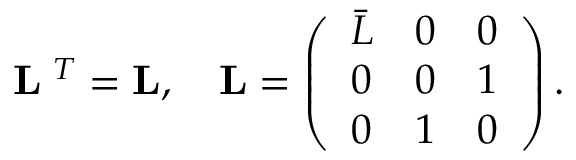Convert formula to latex. <formula><loc_0><loc_0><loc_500><loc_500>{ \Omega } { L } { \Omega } ^ { T } = { L } , \quad { L } = \left ( \begin{array} { l l l } { { \bar { L } } } & { 0 } & { 0 } \\ { 0 } & { 0 } & { 1 } \\ { 0 } & { 1 } & { 0 } \end{array} \right ) .</formula> 